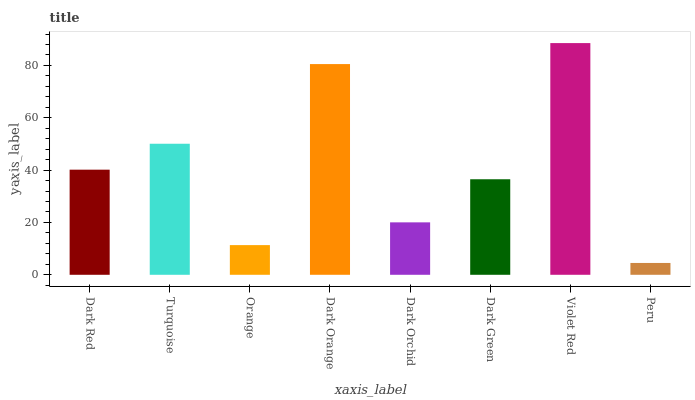Is Turquoise the minimum?
Answer yes or no. No. Is Turquoise the maximum?
Answer yes or no. No. Is Turquoise greater than Dark Red?
Answer yes or no. Yes. Is Dark Red less than Turquoise?
Answer yes or no. Yes. Is Dark Red greater than Turquoise?
Answer yes or no. No. Is Turquoise less than Dark Red?
Answer yes or no. No. Is Dark Red the high median?
Answer yes or no. Yes. Is Dark Green the low median?
Answer yes or no. Yes. Is Dark Orange the high median?
Answer yes or no. No. Is Turquoise the low median?
Answer yes or no. No. 